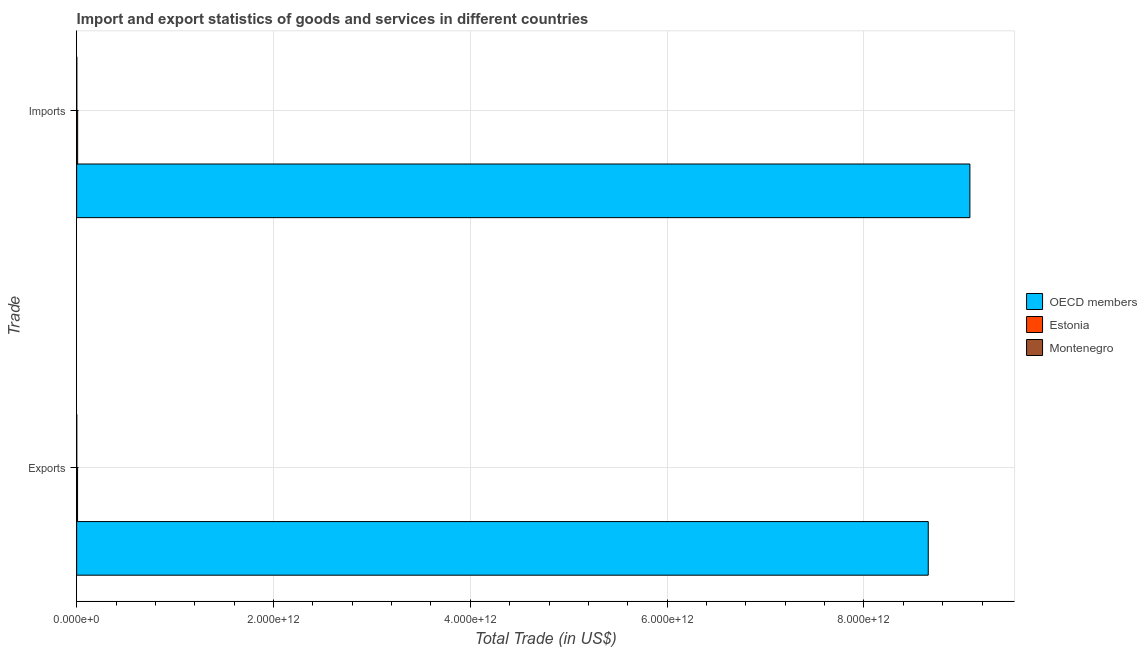How many different coloured bars are there?
Offer a very short reply. 3. Are the number of bars per tick equal to the number of legend labels?
Offer a very short reply. Yes. What is the label of the 1st group of bars from the top?
Your response must be concise. Imports. What is the export of goods and services in Montenegro?
Make the answer very short. 9.83e+08. Across all countries, what is the maximum export of goods and services?
Make the answer very short. 8.65e+12. Across all countries, what is the minimum imports of goods and services?
Offer a very short reply. 1.38e+09. In which country was the export of goods and services minimum?
Give a very brief answer. Montenegro. What is the total export of goods and services in the graph?
Make the answer very short. 8.66e+12. What is the difference between the export of goods and services in OECD members and that in Estonia?
Offer a terse response. 8.64e+12. What is the difference between the imports of goods and services in Montenegro and the export of goods and services in Estonia?
Your answer should be very brief. -7.85e+09. What is the average imports of goods and services per country?
Provide a succinct answer. 3.03e+12. What is the difference between the imports of goods and services and export of goods and services in Estonia?
Your response must be concise. 7.15e+08. In how many countries, is the export of goods and services greater than 5200000000000 US$?
Make the answer very short. 1. What is the ratio of the export of goods and services in OECD members to that in Montenegro?
Your response must be concise. 8803.7. Is the imports of goods and services in Estonia less than that in OECD members?
Ensure brevity in your answer.  Yes. In how many countries, is the export of goods and services greater than the average export of goods and services taken over all countries?
Provide a short and direct response. 1. What does the 2nd bar from the top in Imports represents?
Give a very brief answer. Estonia. How many bars are there?
Make the answer very short. 6. What is the difference between two consecutive major ticks on the X-axis?
Your answer should be very brief. 2.00e+12. Does the graph contain any zero values?
Provide a succinct answer. No. How many legend labels are there?
Give a very brief answer. 3. What is the title of the graph?
Make the answer very short. Import and export statistics of goods and services in different countries. Does "Belgium" appear as one of the legend labels in the graph?
Keep it short and to the point. No. What is the label or title of the X-axis?
Your answer should be very brief. Total Trade (in US$). What is the label or title of the Y-axis?
Ensure brevity in your answer.  Trade. What is the Total Trade (in US$) in OECD members in Exports?
Provide a short and direct response. 8.65e+12. What is the Total Trade (in US$) of Estonia in Exports?
Ensure brevity in your answer.  9.23e+09. What is the Total Trade (in US$) of Montenegro in Exports?
Keep it short and to the point. 9.83e+08. What is the Total Trade (in US$) of OECD members in Imports?
Provide a succinct answer. 9.08e+12. What is the Total Trade (in US$) of Estonia in Imports?
Provide a short and direct response. 9.95e+09. What is the Total Trade (in US$) of Montenegro in Imports?
Your answer should be very brief. 1.38e+09. Across all Trade, what is the maximum Total Trade (in US$) of OECD members?
Offer a very short reply. 9.08e+12. Across all Trade, what is the maximum Total Trade (in US$) of Estonia?
Make the answer very short. 9.95e+09. Across all Trade, what is the maximum Total Trade (in US$) in Montenegro?
Offer a terse response. 1.38e+09. Across all Trade, what is the minimum Total Trade (in US$) in OECD members?
Offer a very short reply. 8.65e+12. Across all Trade, what is the minimum Total Trade (in US$) in Estonia?
Your answer should be compact. 9.23e+09. Across all Trade, what is the minimum Total Trade (in US$) in Montenegro?
Provide a succinct answer. 9.83e+08. What is the total Total Trade (in US$) of OECD members in the graph?
Provide a short and direct response. 1.77e+13. What is the total Total Trade (in US$) in Estonia in the graph?
Ensure brevity in your answer.  1.92e+1. What is the total Total Trade (in US$) of Montenegro in the graph?
Keep it short and to the point. 2.36e+09. What is the difference between the Total Trade (in US$) in OECD members in Exports and that in Imports?
Your answer should be very brief. -4.23e+11. What is the difference between the Total Trade (in US$) of Estonia in Exports and that in Imports?
Give a very brief answer. -7.15e+08. What is the difference between the Total Trade (in US$) in Montenegro in Exports and that in Imports?
Provide a succinct answer. -3.96e+08. What is the difference between the Total Trade (in US$) of OECD members in Exports and the Total Trade (in US$) of Estonia in Imports?
Make the answer very short. 8.64e+12. What is the difference between the Total Trade (in US$) of OECD members in Exports and the Total Trade (in US$) of Montenegro in Imports?
Give a very brief answer. 8.65e+12. What is the difference between the Total Trade (in US$) of Estonia in Exports and the Total Trade (in US$) of Montenegro in Imports?
Give a very brief answer. 7.85e+09. What is the average Total Trade (in US$) of OECD members per Trade?
Provide a short and direct response. 8.87e+12. What is the average Total Trade (in US$) in Estonia per Trade?
Your answer should be very brief. 9.59e+09. What is the average Total Trade (in US$) of Montenegro per Trade?
Provide a short and direct response. 1.18e+09. What is the difference between the Total Trade (in US$) in OECD members and Total Trade (in US$) in Estonia in Exports?
Keep it short and to the point. 8.64e+12. What is the difference between the Total Trade (in US$) of OECD members and Total Trade (in US$) of Montenegro in Exports?
Offer a terse response. 8.65e+12. What is the difference between the Total Trade (in US$) in Estonia and Total Trade (in US$) in Montenegro in Exports?
Provide a succinct answer. 8.25e+09. What is the difference between the Total Trade (in US$) of OECD members and Total Trade (in US$) of Estonia in Imports?
Your answer should be compact. 9.07e+12. What is the difference between the Total Trade (in US$) in OECD members and Total Trade (in US$) in Montenegro in Imports?
Your answer should be very brief. 9.08e+12. What is the difference between the Total Trade (in US$) of Estonia and Total Trade (in US$) of Montenegro in Imports?
Provide a succinct answer. 8.57e+09. What is the ratio of the Total Trade (in US$) of OECD members in Exports to that in Imports?
Your answer should be very brief. 0.95. What is the ratio of the Total Trade (in US$) of Estonia in Exports to that in Imports?
Offer a very short reply. 0.93. What is the ratio of the Total Trade (in US$) in Montenegro in Exports to that in Imports?
Your answer should be compact. 0.71. What is the difference between the highest and the second highest Total Trade (in US$) of OECD members?
Provide a succinct answer. 4.23e+11. What is the difference between the highest and the second highest Total Trade (in US$) of Estonia?
Your answer should be very brief. 7.15e+08. What is the difference between the highest and the second highest Total Trade (in US$) in Montenegro?
Offer a terse response. 3.96e+08. What is the difference between the highest and the lowest Total Trade (in US$) in OECD members?
Keep it short and to the point. 4.23e+11. What is the difference between the highest and the lowest Total Trade (in US$) of Estonia?
Your answer should be very brief. 7.15e+08. What is the difference between the highest and the lowest Total Trade (in US$) of Montenegro?
Give a very brief answer. 3.96e+08. 